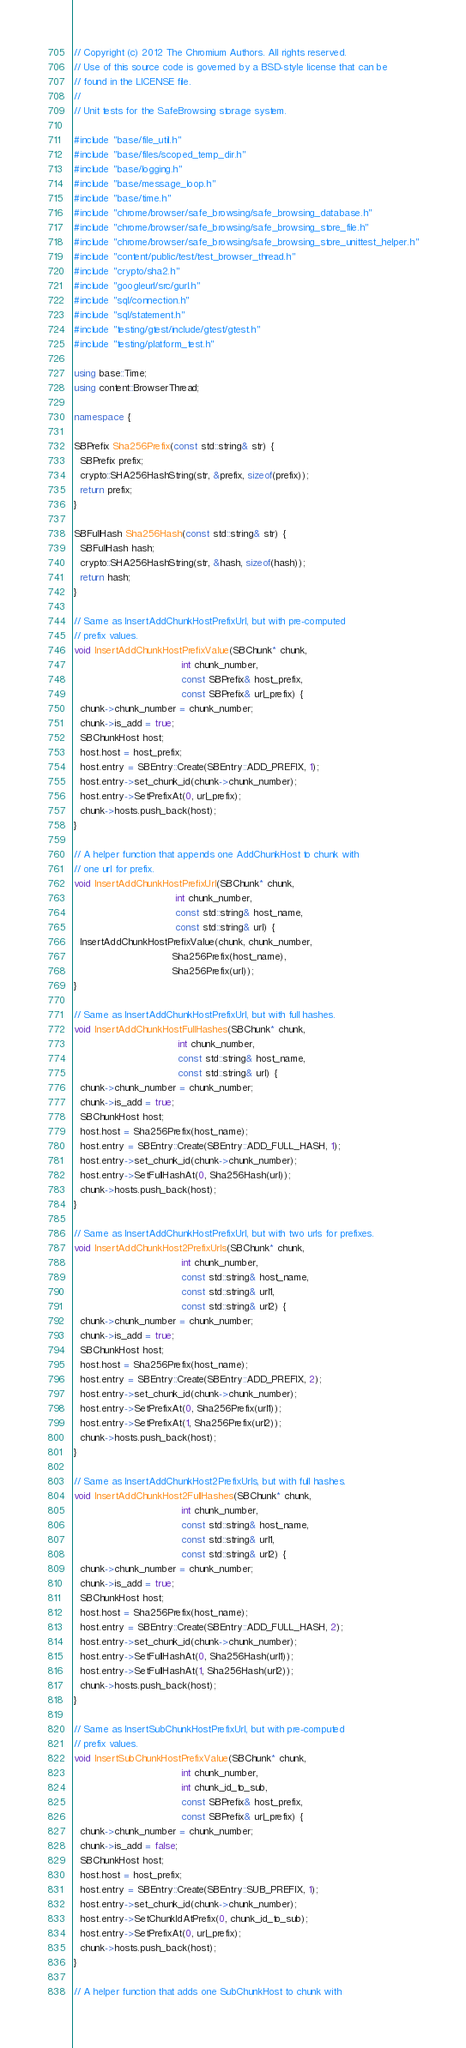Convert code to text. <code><loc_0><loc_0><loc_500><loc_500><_C++_>// Copyright (c) 2012 The Chromium Authors. All rights reserved.
// Use of this source code is governed by a BSD-style license that can be
// found in the LICENSE file.
//
// Unit tests for the SafeBrowsing storage system.

#include "base/file_util.h"
#include "base/files/scoped_temp_dir.h"
#include "base/logging.h"
#include "base/message_loop.h"
#include "base/time.h"
#include "chrome/browser/safe_browsing/safe_browsing_database.h"
#include "chrome/browser/safe_browsing/safe_browsing_store_file.h"
#include "chrome/browser/safe_browsing/safe_browsing_store_unittest_helper.h"
#include "content/public/test/test_browser_thread.h"
#include "crypto/sha2.h"
#include "googleurl/src/gurl.h"
#include "sql/connection.h"
#include "sql/statement.h"
#include "testing/gtest/include/gtest/gtest.h"
#include "testing/platform_test.h"

using base::Time;
using content::BrowserThread;

namespace {

SBPrefix Sha256Prefix(const std::string& str) {
  SBPrefix prefix;
  crypto::SHA256HashString(str, &prefix, sizeof(prefix));
  return prefix;
}

SBFullHash Sha256Hash(const std::string& str) {
  SBFullHash hash;
  crypto::SHA256HashString(str, &hash, sizeof(hash));
  return hash;
}

// Same as InsertAddChunkHostPrefixUrl, but with pre-computed
// prefix values.
void InsertAddChunkHostPrefixValue(SBChunk* chunk,
                                   int chunk_number,
                                   const SBPrefix& host_prefix,
                                   const SBPrefix& url_prefix) {
  chunk->chunk_number = chunk_number;
  chunk->is_add = true;
  SBChunkHost host;
  host.host = host_prefix;
  host.entry = SBEntry::Create(SBEntry::ADD_PREFIX, 1);
  host.entry->set_chunk_id(chunk->chunk_number);
  host.entry->SetPrefixAt(0, url_prefix);
  chunk->hosts.push_back(host);
}

// A helper function that appends one AddChunkHost to chunk with
// one url for prefix.
void InsertAddChunkHostPrefixUrl(SBChunk* chunk,
                                 int chunk_number,
                                 const std::string& host_name,
                                 const std::string& url) {
  InsertAddChunkHostPrefixValue(chunk, chunk_number,
                                Sha256Prefix(host_name),
                                Sha256Prefix(url));
}

// Same as InsertAddChunkHostPrefixUrl, but with full hashes.
void InsertAddChunkHostFullHashes(SBChunk* chunk,
                                  int chunk_number,
                                  const std::string& host_name,
                                  const std::string& url) {
  chunk->chunk_number = chunk_number;
  chunk->is_add = true;
  SBChunkHost host;
  host.host = Sha256Prefix(host_name);
  host.entry = SBEntry::Create(SBEntry::ADD_FULL_HASH, 1);
  host.entry->set_chunk_id(chunk->chunk_number);
  host.entry->SetFullHashAt(0, Sha256Hash(url));
  chunk->hosts.push_back(host);
}

// Same as InsertAddChunkHostPrefixUrl, but with two urls for prefixes.
void InsertAddChunkHost2PrefixUrls(SBChunk* chunk,
                                   int chunk_number,
                                   const std::string& host_name,
                                   const std::string& url1,
                                   const std::string& url2) {
  chunk->chunk_number = chunk_number;
  chunk->is_add = true;
  SBChunkHost host;
  host.host = Sha256Prefix(host_name);
  host.entry = SBEntry::Create(SBEntry::ADD_PREFIX, 2);
  host.entry->set_chunk_id(chunk->chunk_number);
  host.entry->SetPrefixAt(0, Sha256Prefix(url1));
  host.entry->SetPrefixAt(1, Sha256Prefix(url2));
  chunk->hosts.push_back(host);
}

// Same as InsertAddChunkHost2PrefixUrls, but with full hashes.
void InsertAddChunkHost2FullHashes(SBChunk* chunk,
                                   int chunk_number,
                                   const std::string& host_name,
                                   const std::string& url1,
                                   const std::string& url2) {
  chunk->chunk_number = chunk_number;
  chunk->is_add = true;
  SBChunkHost host;
  host.host = Sha256Prefix(host_name);
  host.entry = SBEntry::Create(SBEntry::ADD_FULL_HASH, 2);
  host.entry->set_chunk_id(chunk->chunk_number);
  host.entry->SetFullHashAt(0, Sha256Hash(url1));
  host.entry->SetFullHashAt(1, Sha256Hash(url2));
  chunk->hosts.push_back(host);
}

// Same as InsertSubChunkHostPrefixUrl, but with pre-computed
// prefix values.
void InsertSubChunkHostPrefixValue(SBChunk* chunk,
                                   int chunk_number,
                                   int chunk_id_to_sub,
                                   const SBPrefix& host_prefix,
                                   const SBPrefix& url_prefix) {
  chunk->chunk_number = chunk_number;
  chunk->is_add = false;
  SBChunkHost host;
  host.host = host_prefix;
  host.entry = SBEntry::Create(SBEntry::SUB_PREFIX, 1);
  host.entry->set_chunk_id(chunk->chunk_number);
  host.entry->SetChunkIdAtPrefix(0, chunk_id_to_sub);
  host.entry->SetPrefixAt(0, url_prefix);
  chunk->hosts.push_back(host);
}

// A helper function that adds one SubChunkHost to chunk with</code> 